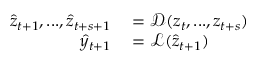<formula> <loc_0><loc_0><loc_500><loc_500>\begin{array} { r l } { \hat { z } _ { t + 1 } , \dots , \hat { z } _ { t + s + 1 } } & = \mathcal { D } ( z _ { t } , \dots , z _ { t + s } ) } \\ { \hat { y } _ { t + 1 } } & = \mathcal { L } ( \hat { z } _ { t + 1 } ) } \end{array}</formula> 